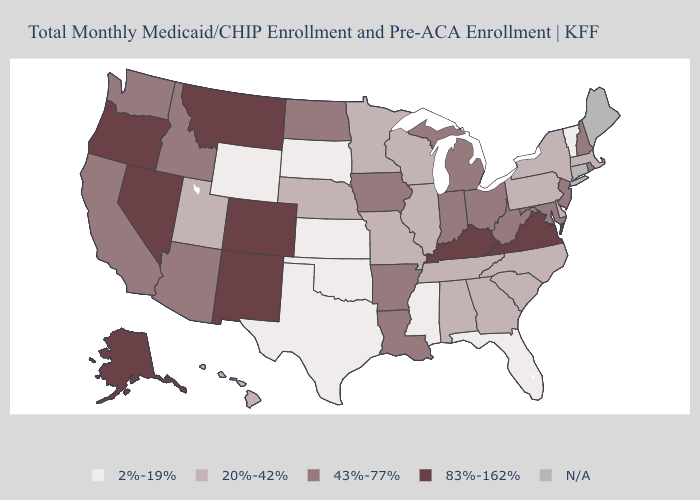Name the states that have a value in the range 83%-162%?
Write a very short answer. Alaska, Colorado, Kentucky, Montana, Nevada, New Mexico, Oregon, Virginia. Name the states that have a value in the range 83%-162%?
Answer briefly. Alaska, Colorado, Kentucky, Montana, Nevada, New Mexico, Oregon, Virginia. Name the states that have a value in the range N/A?
Short answer required. Connecticut, Maine. Name the states that have a value in the range 43%-77%?
Write a very short answer. Arizona, Arkansas, California, Idaho, Indiana, Iowa, Louisiana, Maryland, Michigan, New Hampshire, New Jersey, North Dakota, Ohio, Rhode Island, Washington, West Virginia. What is the value of Utah?
Be succinct. 20%-42%. Name the states that have a value in the range 83%-162%?
Short answer required. Alaska, Colorado, Kentucky, Montana, Nevada, New Mexico, Oregon, Virginia. Among the states that border Massachusetts , does Rhode Island have the lowest value?
Write a very short answer. No. What is the value of South Carolina?
Quick response, please. 20%-42%. What is the value of Nebraska?
Answer briefly. 20%-42%. Name the states that have a value in the range 83%-162%?
Keep it brief. Alaska, Colorado, Kentucky, Montana, Nevada, New Mexico, Oregon, Virginia. What is the value of North Carolina?
Write a very short answer. 20%-42%. Which states hav the highest value in the Northeast?
Short answer required. New Hampshire, New Jersey, Rhode Island. Does Kansas have the lowest value in the MidWest?
Answer briefly. Yes. Does the first symbol in the legend represent the smallest category?
Answer briefly. Yes. 